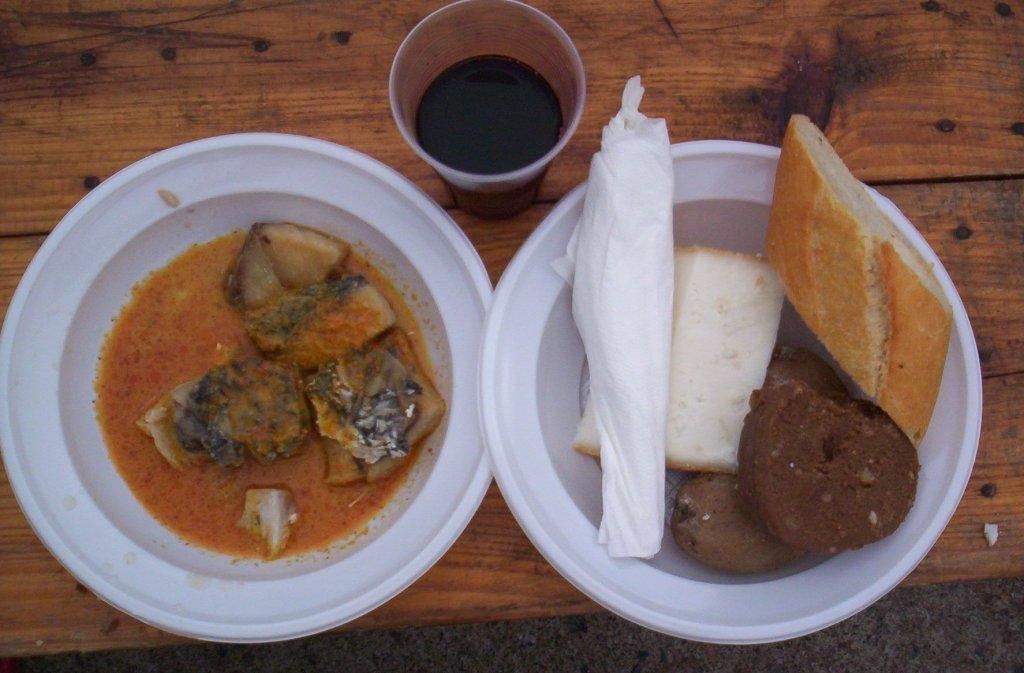What piece of furniture is present in the image? There is a table in the image. What is placed on the table? There are plates on the table. What is in the plates? There is a food item in the plates. What is beside the plate? There is a glass beside the plate. What is inside the glass? There is a liquid in the glass. Can you see a ghost interacting with the food in the image? No, there is no ghost present in the image. What type of structure is the monkey climbing on in the image? There is no monkey present in the image. 